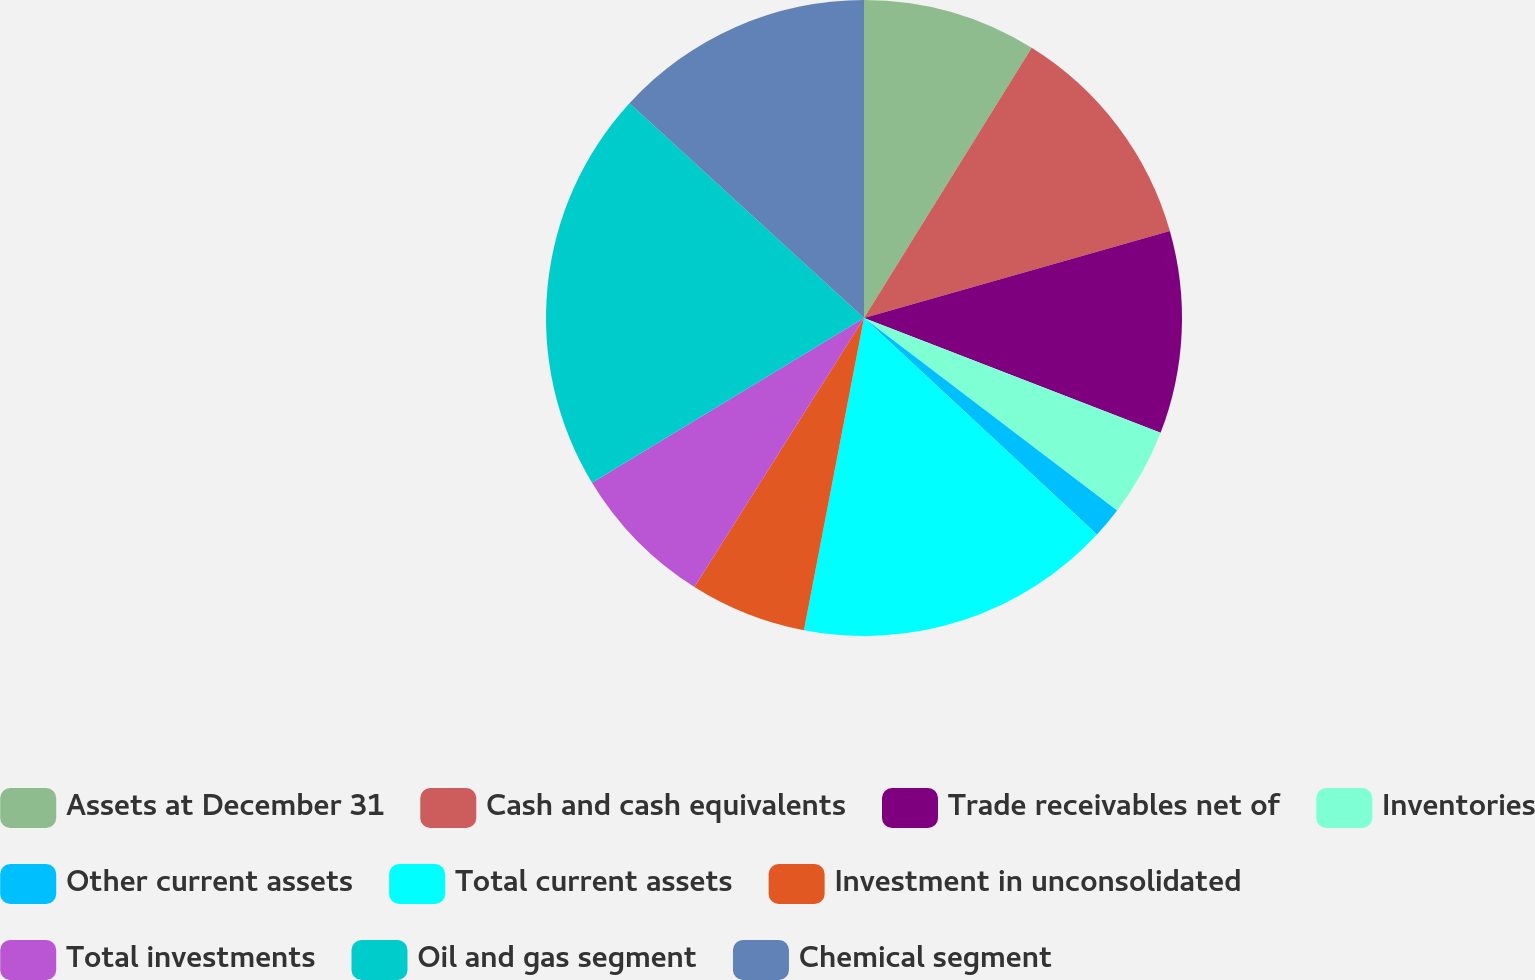Convert chart. <chart><loc_0><loc_0><loc_500><loc_500><pie_chart><fcel>Assets at December 31<fcel>Cash and cash equivalents<fcel>Trade receivables net of<fcel>Inventories<fcel>Other current assets<fcel>Total current assets<fcel>Investment in unconsolidated<fcel>Total investments<fcel>Oil and gas segment<fcel>Chemical segment<nl><fcel>8.84%<fcel>11.75%<fcel>10.29%<fcel>4.47%<fcel>1.57%<fcel>16.11%<fcel>5.93%<fcel>7.38%<fcel>20.47%<fcel>13.2%<nl></chart> 